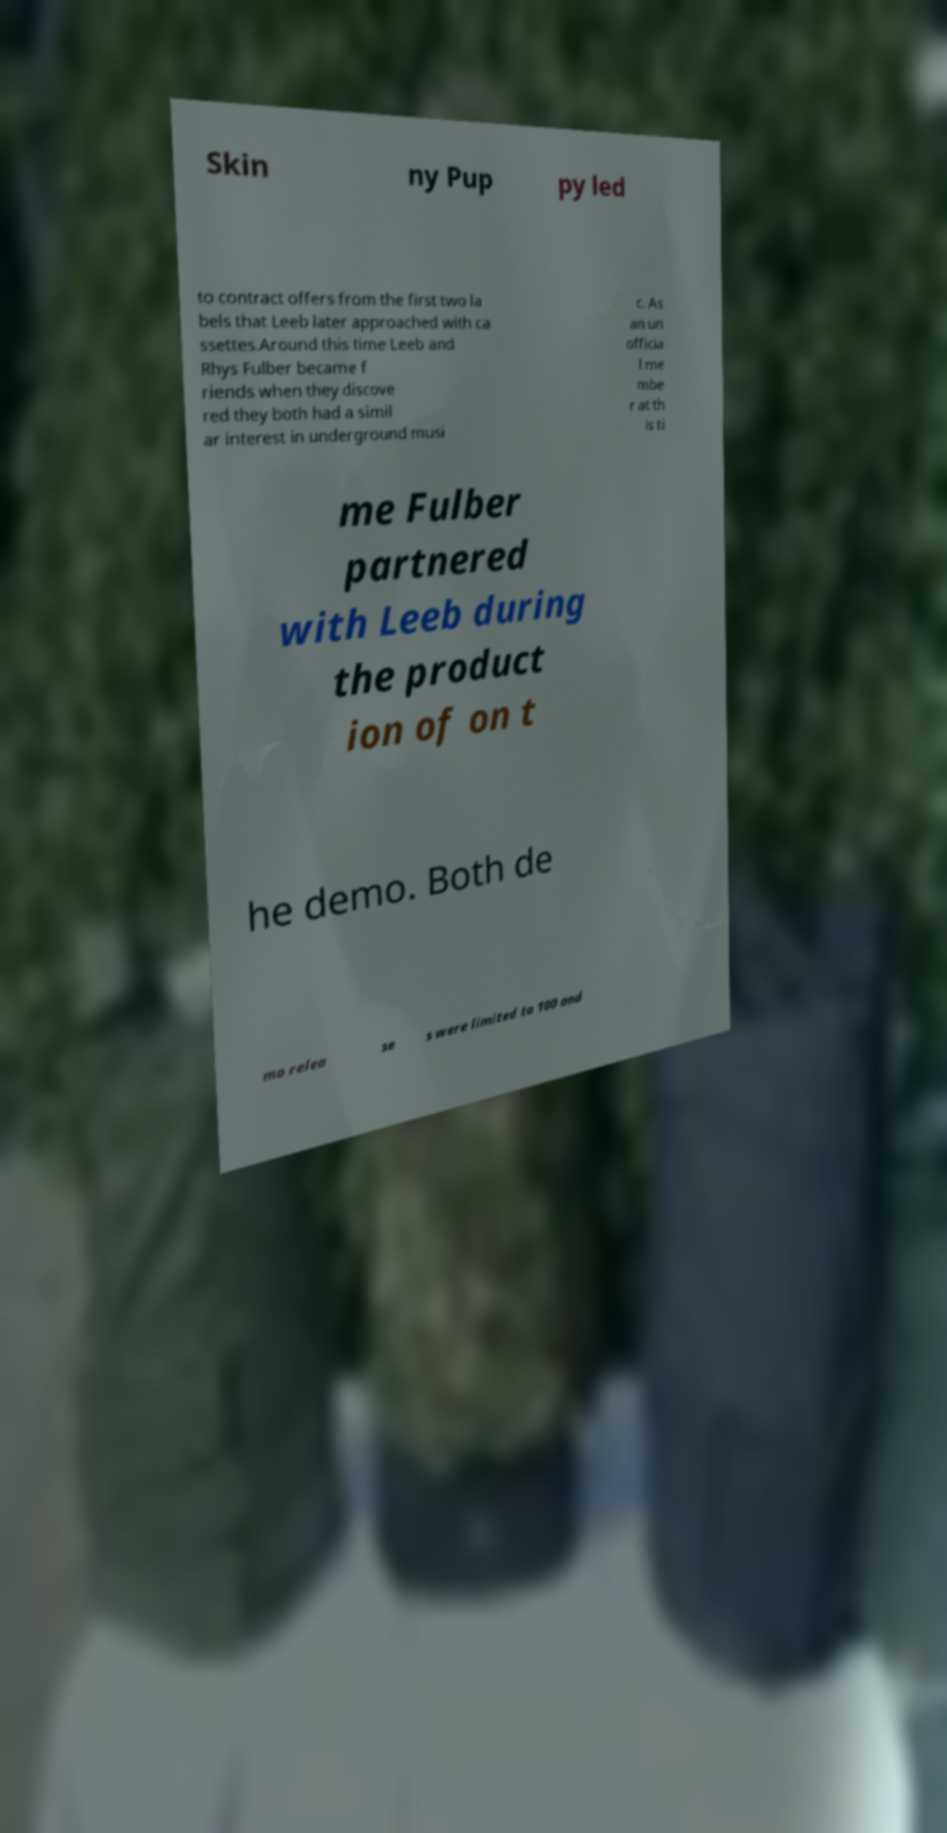I need the written content from this picture converted into text. Can you do that? Skin ny Pup py led to contract offers from the first two la bels that Leeb later approached with ca ssettes.Around this time Leeb and Rhys Fulber became f riends when they discove red they both had a simil ar interest in underground musi c. As an un officia l me mbe r at th is ti me Fulber partnered with Leeb during the product ion of on t he demo. Both de mo relea se s were limited to 100 and 